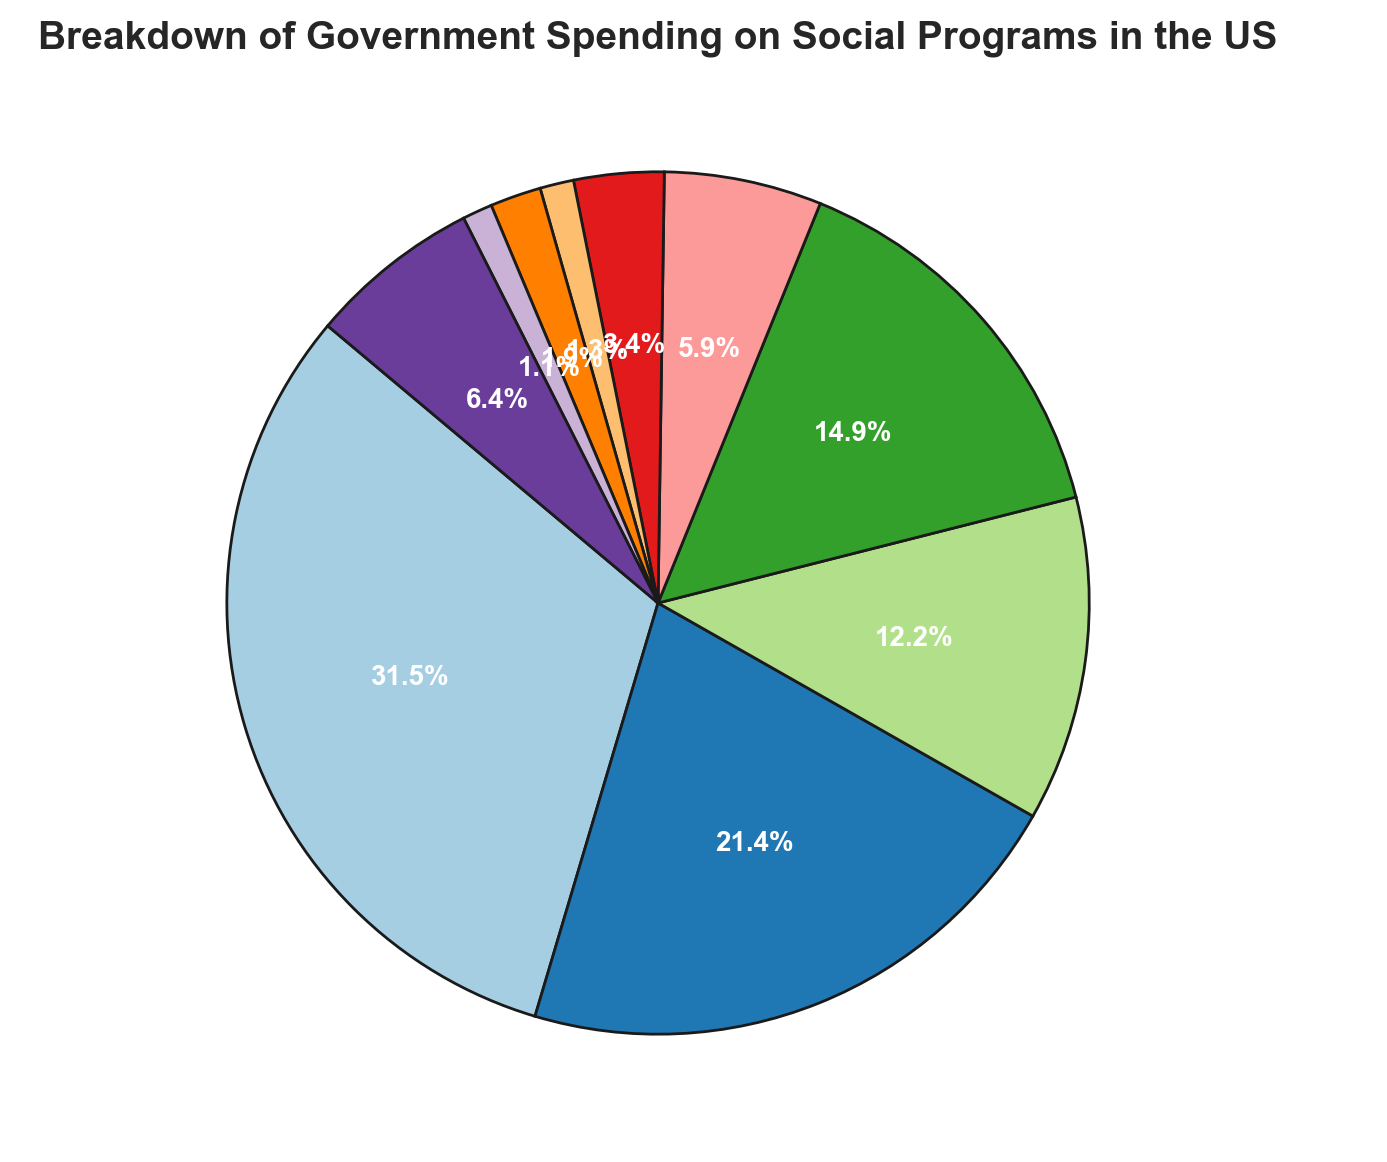What percentage of the government spending on social programs is allocated to Medicare? The figure indicates the percentage allocation for each category. According to the pie chart, Medicare accounts for a specific wedge. Referring to the label on the pie chart, Medicare is allocated 760 billion USD which translates to a certain percentage. This percentage can be directly read from the pie chart.
Answer: 23.5% What are the combined spending percentages of Social Security and Medicaid and CHIP? To find the combined spending percentage, identify the percentages for Social Security and Medicaid and CHIP from the pie chart. Social Security is allocated 1,120 billion USD and Medicaid and CHIP are allocated 433 billion USD. Add their respective percentages from the pie chart.
Answer: 43% Which category has the smallest allocation in terms of government spending? The category with the smallest allocation can be identified by the smallest wedge in the pie chart. By visual inspection, the smallest wedge corresponds to the expenditure on Unemployment Compensation.
Answer: Unemployment Compensation How much more is spent on Social Security compared to Income Security Programs? To find the difference in spending between Social Security and Income Security Programs, look at their respective allocations. Social Security is allocated 1,120 billion USD and Income Security Programs are allocated 530 billion USD. Subtract the latter from the former.
Answer: 590 billion USD Which categories combined amount to less than 10% of the total spending? To determine which categories combined amount to less than 10% of the total spending, identify the categories with small percentages from the pie chart like Housing Assistance, Food Assistance, Unemployment Compensation, and Education Subsidies. Individually add their percentages until the total is less than 10%.
Answer: Housing Assistance, Food Assistance, and Unemployment Compensation What is the average amount spent across all categories? To find the average spending, sum all the amounts and divide by the number of categories (10). The total amount is the sum of (1,120 + 760 + 433 + 530 + 210 + 120 + 45 + 68 + 40 + 229) billion USD. Divide this sum by 10.
Answer: 455.5 billion USD How does the spending on Veterans Benefits and Services compare to that on Education Subsidies? Compare the respective amounts allocated to Veterans Benefits and Services (210 billion USD) and Education Subsidies (120 billion USD). Veterans Benefits and Services is larger.
Answer: Veterans Benefits and Services is greater Which category occupies approximately one-third of the pie chart? Identify the category whose wedge represents approximately one-third of the pie chart. This can be done by visually inspecting the sizes of the wedges. Social Security occupies roughly one-third.
Answer: Social Security 